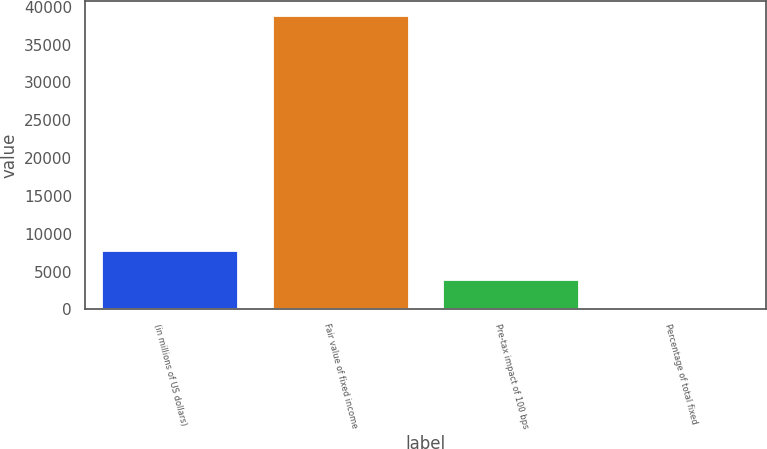<chart> <loc_0><loc_0><loc_500><loc_500><bar_chart><fcel>(in millions of US dollars)<fcel>Fair value of fixed income<fcel>Pre-tax impact of 100 bps<fcel>Percentage of total fixed<nl><fcel>7768.64<fcel>38830<fcel>3885.97<fcel>3.3<nl></chart> 